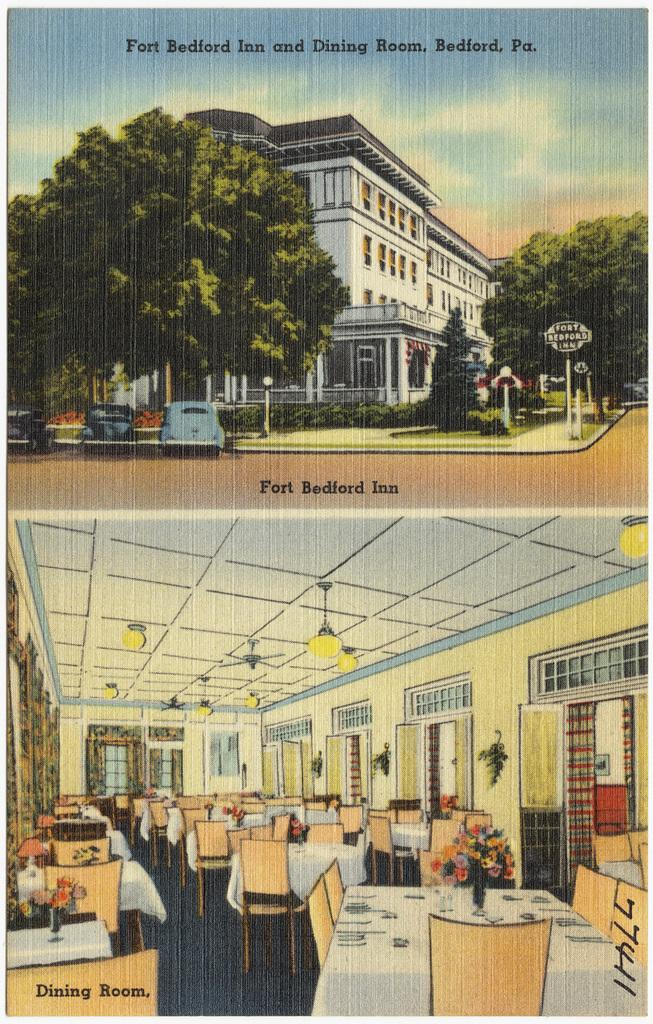<image>
Share a concise interpretation of the image provided. An old ad for the Fort Bedford Inn that looks drawn. 